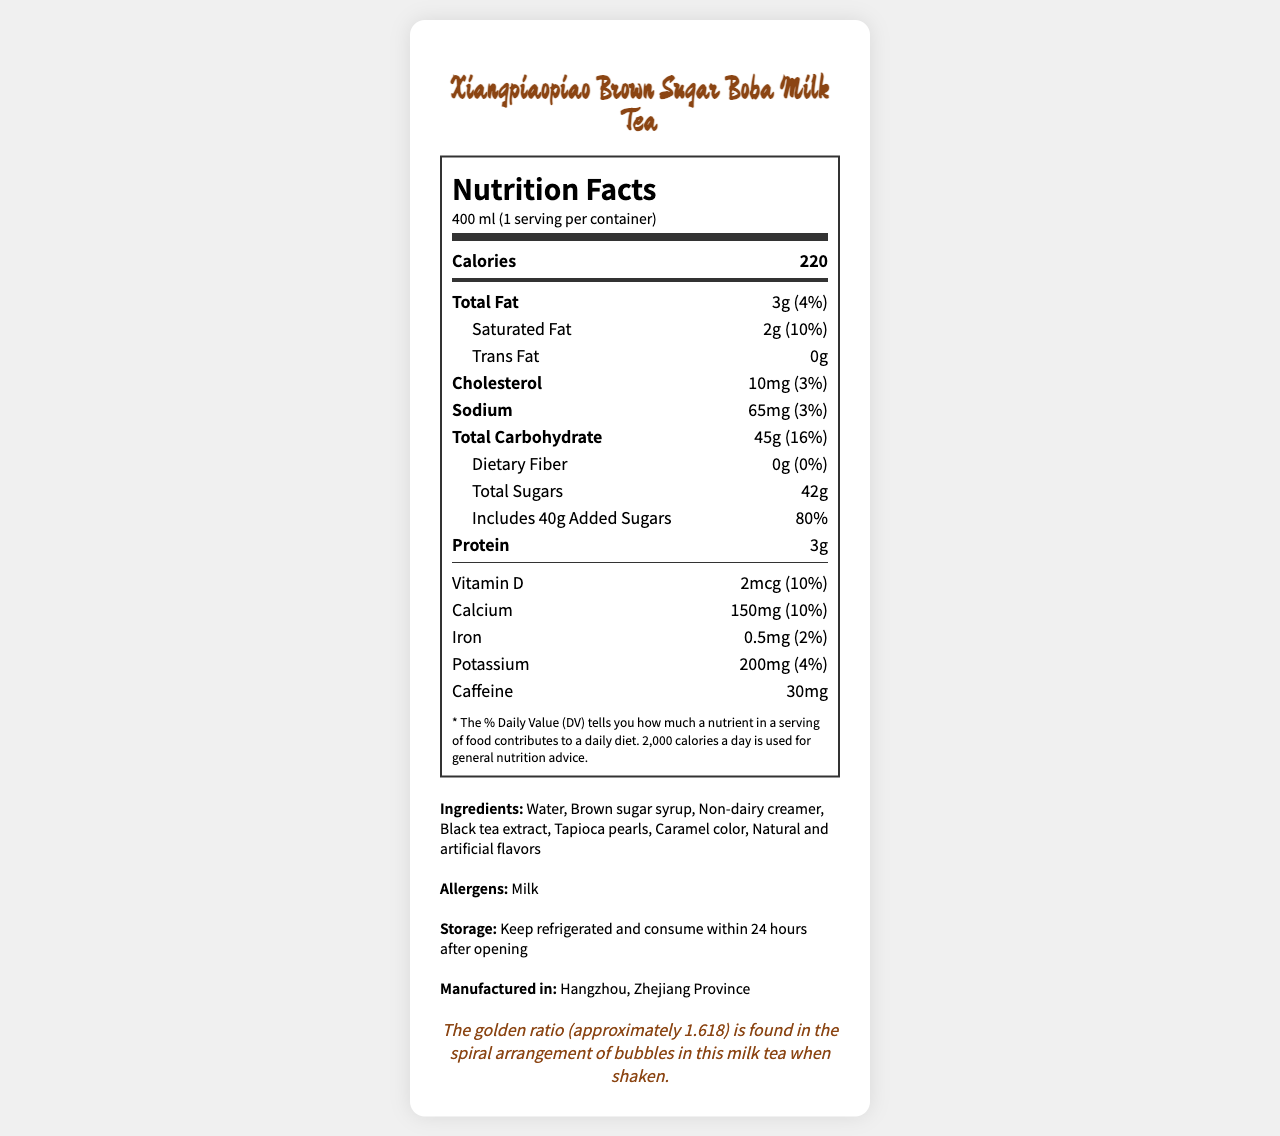what is the sugar content in this milk tea? The document lists the total sugars as 42g under the "Total Sugars" section.
Answer: 42g how much caffeine is present in a serving? The caffeine content is mentioned as 30mg in the document.
Answer: 30mg what is the serving size of the product? The serving size is shown as 400 ml on the nutrition label.
Answer: 400 ml which vitamin is present in 10% daily value? The document shows that Vitamin D has a 10% daily value based on 2mcg.
Answer: Vitamin D how much calcium is in this product? The amount of calcium is listed as 150mg with a 10% daily value.
Answer: 150mg does this product contain any trans fat? The document states that trans fat is 0g.
Answer: No what percentage of the daily value for added sugars does this product provide? The added sugars amount to 40g, which is 80% of the daily value.
Answer: 80% what is the total carbohydrate content? A. 30g B. 55g C. 45g D. 50g The total carbohydrate content is 45g as stated in the document.
Answer: C which ingredient is listed first? A. Non-dairy creamer B. Brown sugar syrup C. Water D. Black tea extract Water is the first ingredient listed.
Answer: C how many servings are there per container? The document shows that there is 1 serving per container.
Answer: 1 is this product allergen-free? The document lists milk as an allergen, indicating it is not allergen-free.
Answer: No describe the main idea of the document. The main idea of the document revolves around giving consumers comprehensive insight into the nutritional values, ingredients, and other relevant details of the Xiangpiaopiao Brown Sugar Boba Milk Tea.
Answer: The document provides a detailed nutritional breakdown of Xiangpiaopiao Brown Sugar Boba Milk Tea, including information about serving size, calorie count, fats, cholesterol, sodium, carbohydrates, protein, vitamins, minerals, caffeine content, ingredients, allergens, storage instructions, and manufacturing location. how much protein is in one serving? The protein content is specified as 3g in the document.
Answer: 3g where is the product manufactured? The document states that the manufacturing location is Hangzhou, Zhejiang Province.
Answer: Hangzhou, Zhejiang Province how long should the product be consumed after opening? The storage instructions mention that it should be consumed within 24 hours after opening.
Answer: Within 24 hours what is the saturation fat content and its daily value percentage? The saturated fat content is 2g, which is 10% of the daily value.
Answer: 2g, 10% does the product contain any dietary fiber? The document indicates that dietary fiber content is 0g.
Answer: No which element has the highest daily value percentage in this product? A. Calcium B. Sodium C. Added Sugars D. Potassium Added sugars have the highest daily value percentage at 80%.
Answer: C what are the natural and artificial flavors in the product? The document mentions natural and artificial flavors but does not specify what they are.
Answer: Cannot be determined 